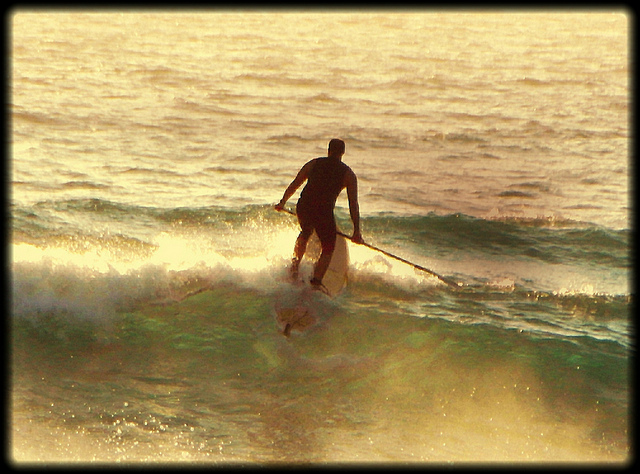Imagine the man suddenly encounters a pod of dolphins. How might this experience change? Encountering a pod of dolphins could transform the man's paddleboarding session into a magical experience. Dolphins are known for their playful nature, and they might swim nearby, leap out of the water, and even interact with him if he’s lucky. This encounter would likely fill him with awe and might make for an unforgettable moment, blending the thrills of paddleboarding with the wonder of marine wildlife. 